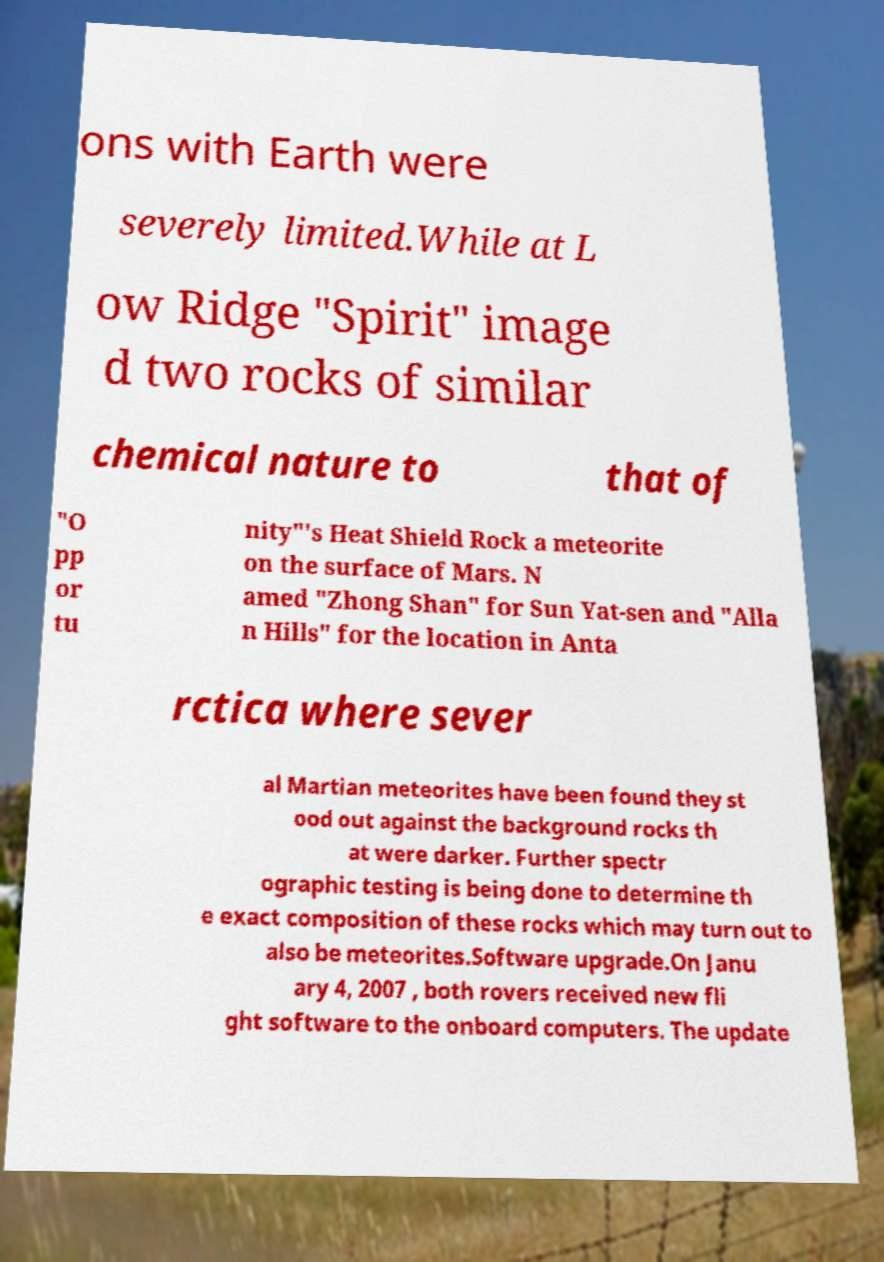For documentation purposes, I need the text within this image transcribed. Could you provide that? ons with Earth were severely limited.While at L ow Ridge "Spirit" image d two rocks of similar chemical nature to that of "O pp or tu nity"'s Heat Shield Rock a meteorite on the surface of Mars. N amed "Zhong Shan" for Sun Yat-sen and "Alla n Hills" for the location in Anta rctica where sever al Martian meteorites have been found they st ood out against the background rocks th at were darker. Further spectr ographic testing is being done to determine th e exact composition of these rocks which may turn out to also be meteorites.Software upgrade.On Janu ary 4, 2007 , both rovers received new fli ght software to the onboard computers. The update 